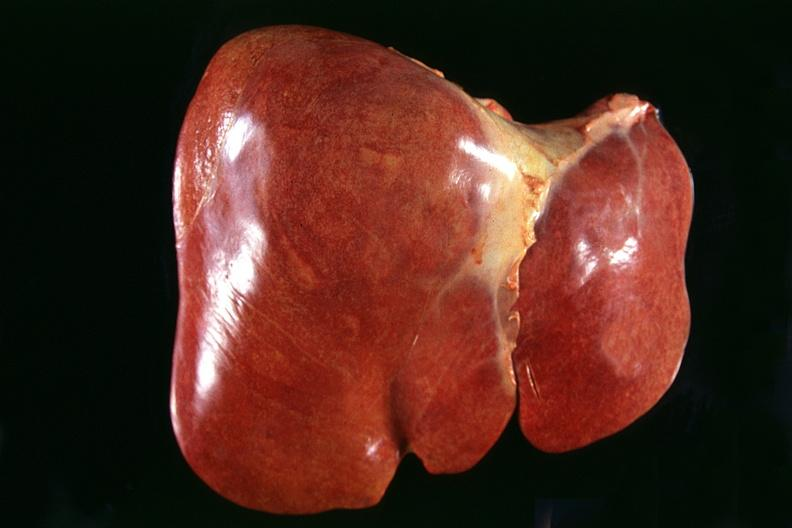s peritoneal fluid present?
Answer the question using a single word or phrase. No 